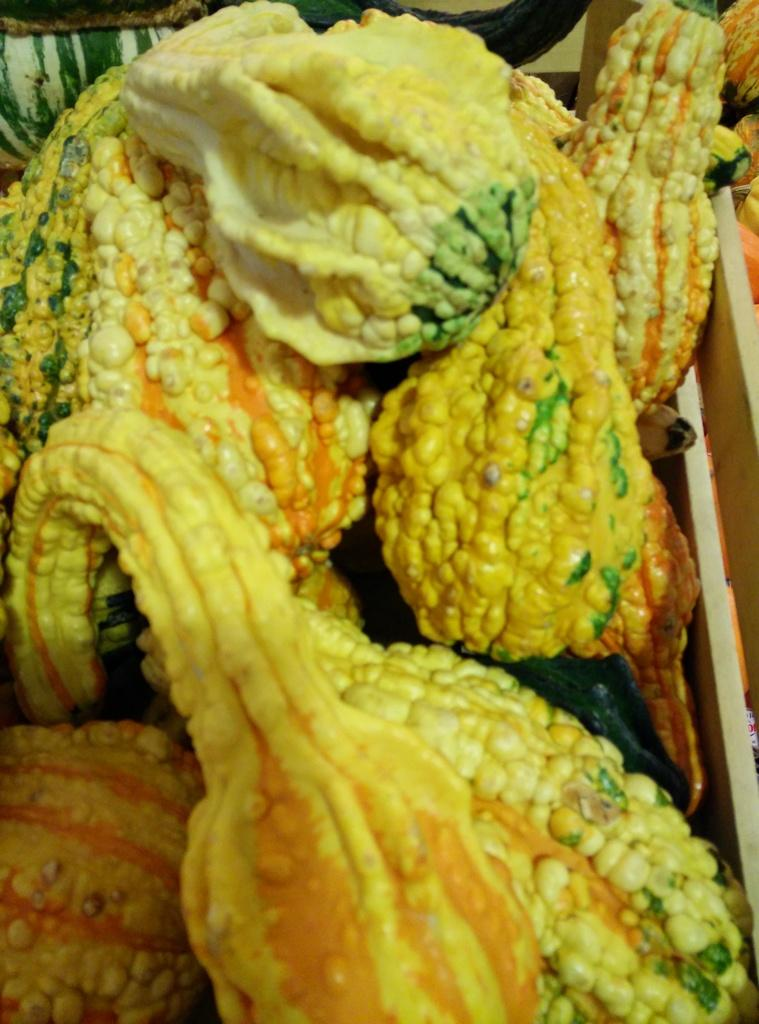What type of objects are in the image? There are gourds in the image. Where are the gourds located? The gourds are in a wooden box. How does the secretary help with the gourds in the image? There is no secretary present in the image, as the facts only mention gourds and a wooden box. 